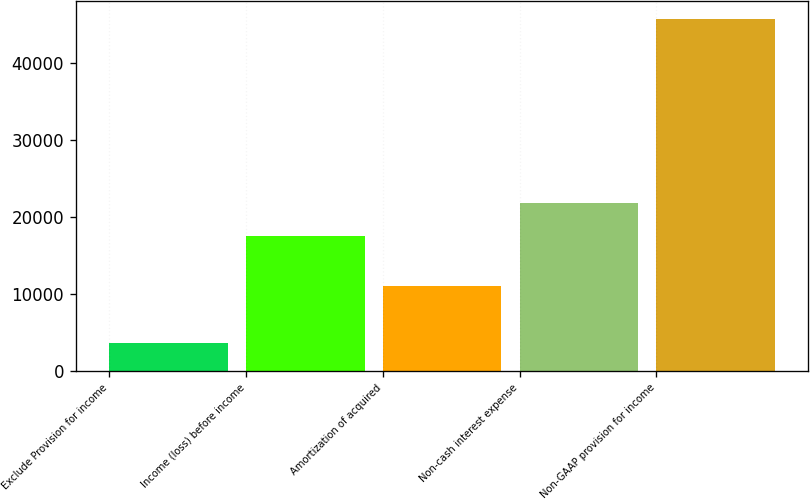Convert chart to OTSL. <chart><loc_0><loc_0><loc_500><loc_500><bar_chart><fcel>Exclude Provision for income<fcel>Income (loss) before income<fcel>Amortization of acquired<fcel>Non-cash interest expense<fcel>Non-GAAP provision for income<nl><fcel>3564<fcel>17531<fcel>11077<fcel>21746.6<fcel>45720<nl></chart> 